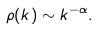Convert formula to latex. <formula><loc_0><loc_0><loc_500><loc_500>\rho ( k ) \sim k ^ { - \alpha } .</formula> 